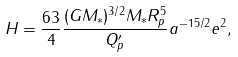<formula> <loc_0><loc_0><loc_500><loc_500>H = \frac { 6 3 } { 4 } \frac { ( G M _ { * } ) ^ { 3 / 2 } M _ { * } R _ { p } ^ { 5 } } { Q ^ { \prime } _ { p } } a ^ { - 1 5 / 2 } e ^ { 2 } ,</formula> 